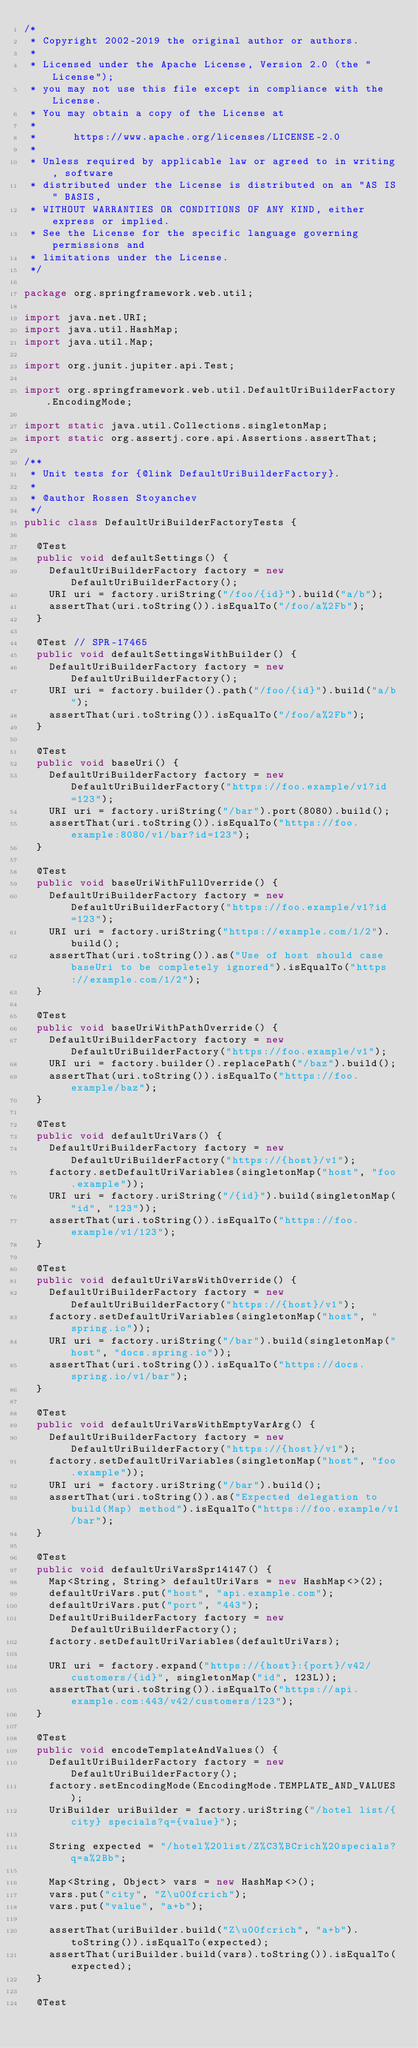<code> <loc_0><loc_0><loc_500><loc_500><_Java_>/*
 * Copyright 2002-2019 the original author or authors.
 *
 * Licensed under the Apache License, Version 2.0 (the "License");
 * you may not use this file except in compliance with the License.
 * You may obtain a copy of the License at
 *
 *      https://www.apache.org/licenses/LICENSE-2.0
 *
 * Unless required by applicable law or agreed to in writing, software
 * distributed under the License is distributed on an "AS IS" BASIS,
 * WITHOUT WARRANTIES OR CONDITIONS OF ANY KIND, either express or implied.
 * See the License for the specific language governing permissions and
 * limitations under the License.
 */

package org.springframework.web.util;

import java.net.URI;
import java.util.HashMap;
import java.util.Map;

import org.junit.jupiter.api.Test;

import org.springframework.web.util.DefaultUriBuilderFactory.EncodingMode;

import static java.util.Collections.singletonMap;
import static org.assertj.core.api.Assertions.assertThat;

/**
 * Unit tests for {@link DefaultUriBuilderFactory}.
 *
 * @author Rossen Stoyanchev
 */
public class DefaultUriBuilderFactoryTests {

	@Test
	public void defaultSettings() {
		DefaultUriBuilderFactory factory = new DefaultUriBuilderFactory();
		URI uri = factory.uriString("/foo/{id}").build("a/b");
		assertThat(uri.toString()).isEqualTo("/foo/a%2Fb");
	}

	@Test // SPR-17465
	public void defaultSettingsWithBuilder() {
		DefaultUriBuilderFactory factory = new DefaultUriBuilderFactory();
		URI uri = factory.builder().path("/foo/{id}").build("a/b");
		assertThat(uri.toString()).isEqualTo("/foo/a%2Fb");
	}

	@Test
	public void baseUri() {
		DefaultUriBuilderFactory factory = new DefaultUriBuilderFactory("https://foo.example/v1?id=123");
		URI uri = factory.uriString("/bar").port(8080).build();
		assertThat(uri.toString()).isEqualTo("https://foo.example:8080/v1/bar?id=123");
	}

	@Test
	public void baseUriWithFullOverride() {
		DefaultUriBuilderFactory factory = new DefaultUriBuilderFactory("https://foo.example/v1?id=123");
		URI uri = factory.uriString("https://example.com/1/2").build();
		assertThat(uri.toString()).as("Use of host should case baseUri to be completely ignored").isEqualTo("https://example.com/1/2");
	}

	@Test
	public void baseUriWithPathOverride() {
		DefaultUriBuilderFactory factory = new DefaultUriBuilderFactory("https://foo.example/v1");
		URI uri = factory.builder().replacePath("/baz").build();
		assertThat(uri.toString()).isEqualTo("https://foo.example/baz");
	}

	@Test
	public void defaultUriVars() {
		DefaultUriBuilderFactory factory = new DefaultUriBuilderFactory("https://{host}/v1");
		factory.setDefaultUriVariables(singletonMap("host", "foo.example"));
		URI uri = factory.uriString("/{id}").build(singletonMap("id", "123"));
		assertThat(uri.toString()).isEqualTo("https://foo.example/v1/123");
	}

	@Test
	public void defaultUriVarsWithOverride() {
		DefaultUriBuilderFactory factory = new DefaultUriBuilderFactory("https://{host}/v1");
		factory.setDefaultUriVariables(singletonMap("host", "spring.io"));
		URI uri = factory.uriString("/bar").build(singletonMap("host", "docs.spring.io"));
		assertThat(uri.toString()).isEqualTo("https://docs.spring.io/v1/bar");
	}

	@Test
	public void defaultUriVarsWithEmptyVarArg() {
		DefaultUriBuilderFactory factory = new DefaultUriBuilderFactory("https://{host}/v1");
		factory.setDefaultUriVariables(singletonMap("host", "foo.example"));
		URI uri = factory.uriString("/bar").build();
		assertThat(uri.toString()).as("Expected delegation to build(Map) method").isEqualTo("https://foo.example/v1/bar");
	}

	@Test
	public void defaultUriVarsSpr14147() {
		Map<String, String> defaultUriVars = new HashMap<>(2);
		defaultUriVars.put("host", "api.example.com");
		defaultUriVars.put("port", "443");
		DefaultUriBuilderFactory factory = new DefaultUriBuilderFactory();
		factory.setDefaultUriVariables(defaultUriVars);

		URI uri = factory.expand("https://{host}:{port}/v42/customers/{id}", singletonMap("id", 123L));
		assertThat(uri.toString()).isEqualTo("https://api.example.com:443/v42/customers/123");
	}

	@Test
	public void encodeTemplateAndValues() {
		DefaultUriBuilderFactory factory = new DefaultUriBuilderFactory();
		factory.setEncodingMode(EncodingMode.TEMPLATE_AND_VALUES);
		UriBuilder uriBuilder = factory.uriString("/hotel list/{city} specials?q={value}");

		String expected = "/hotel%20list/Z%C3%BCrich%20specials?q=a%2Bb";

		Map<String, Object> vars = new HashMap<>();
		vars.put("city", "Z\u00fcrich");
		vars.put("value", "a+b");

		assertThat(uriBuilder.build("Z\u00fcrich", "a+b").toString()).isEqualTo(expected);
		assertThat(uriBuilder.build(vars).toString()).isEqualTo(expected);
	}

	@Test</code> 